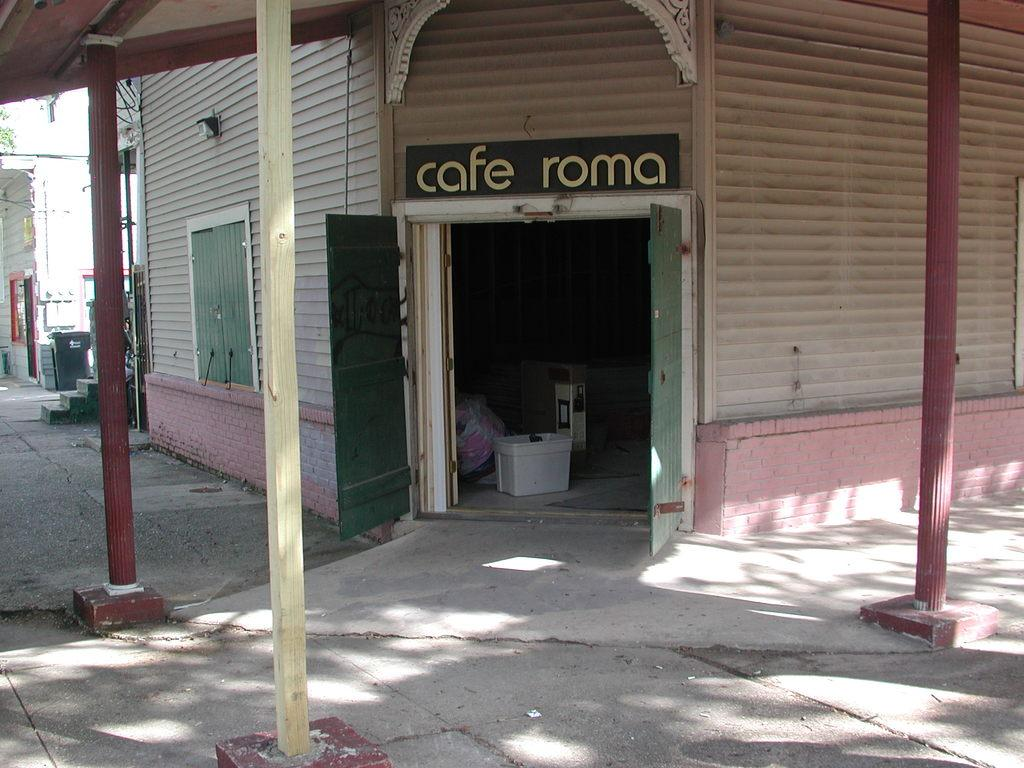What type of structures can be seen in the image? There are buildings in the image. What architectural features are present on the buildings? There are windows, doors, stairs, and poles in the image. What is used for waste disposal in the image? There are dustbins in the image. What might be found inside the buildings? There are objects inside the building in the image. What month is it in the image? The month cannot be determined from the image, as it does not contain any information about the time or date. 